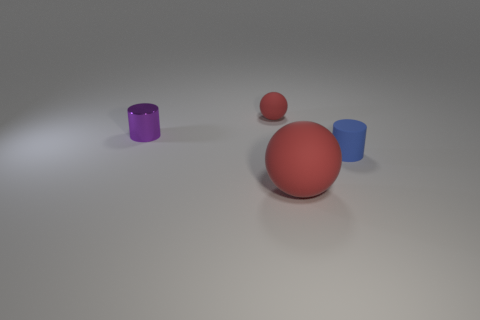Can you describe the lighting in the scene? The lighting in the image seems to come from above, creating soft shadows beneath the objects. It's likely a diffused light source, given the smooth shadow gradients and the lack of harsh highlights on the objects. 